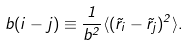<formula> <loc_0><loc_0><loc_500><loc_500>b ( i - j ) \equiv \frac { 1 } { b ^ { 2 } } \langle ( \vec { r } _ { i } - \vec { r } _ { j } ) ^ { 2 } \rangle .</formula> 